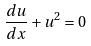Convert formula to latex. <formula><loc_0><loc_0><loc_500><loc_500>\frac { d u } { d x } + u ^ { 2 } = 0</formula> 